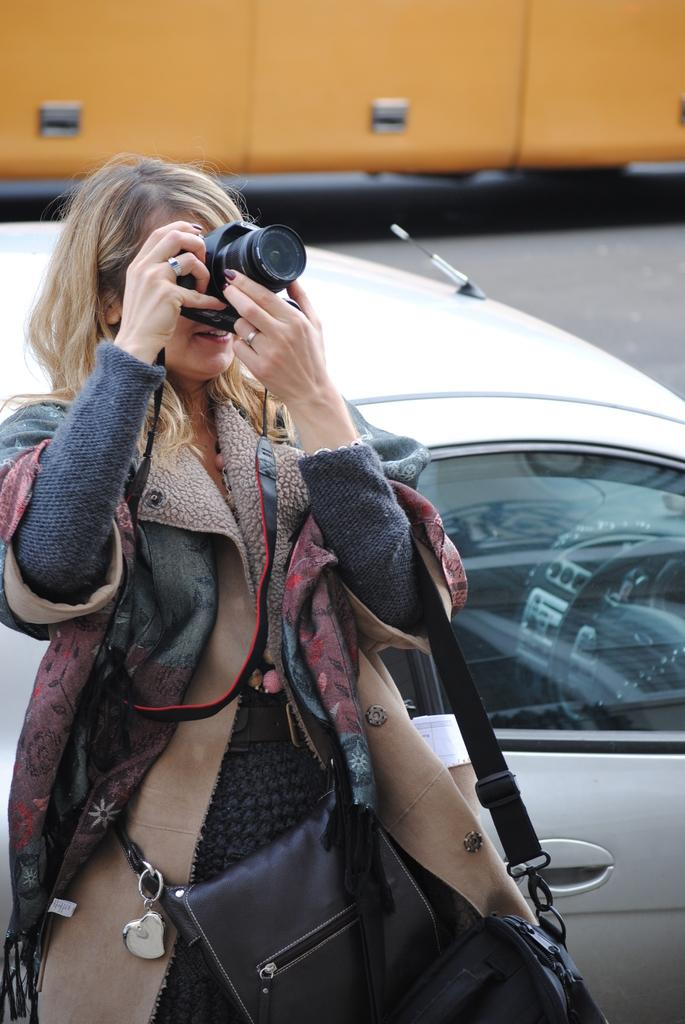Who is the main subject in the image? There is a woman in the image. What is the woman doing in the image? The woman is capturing an image with a camera. What else can be seen that the woman is carrying? The woman is carrying a bag. What is visible behind the woman? There is a car behind the woman. What type of surface is visible in the image? There is a road in the image. What is the cause of the woman's sudden walk in the image? There is no indication in the image that the woman is walking suddenly or that there is a cause for it. 